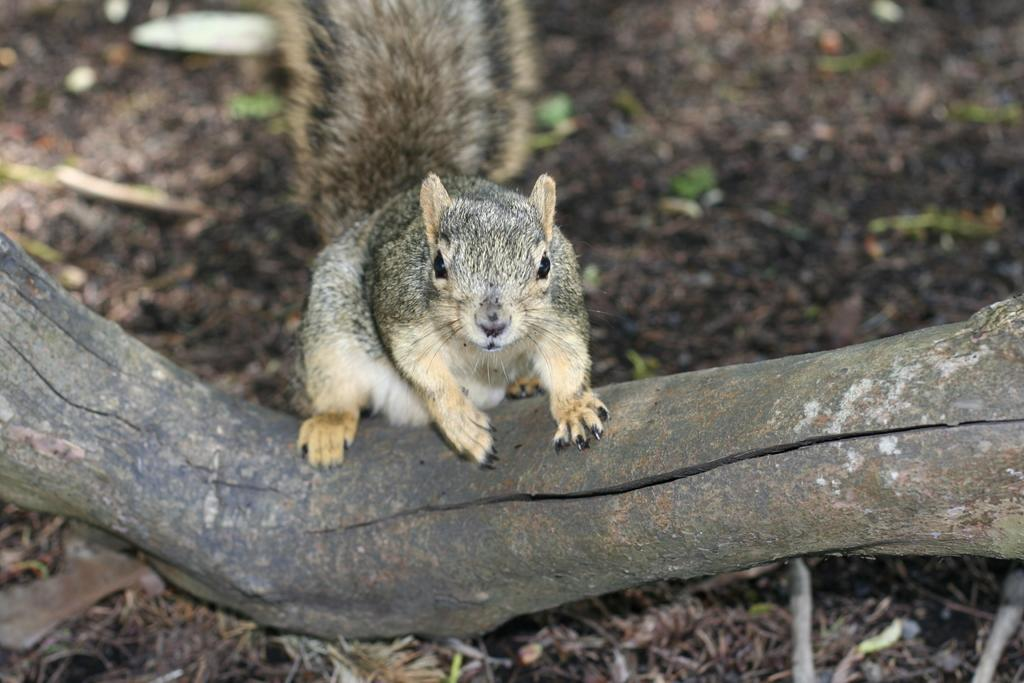What animal is the main subject of the image? There is a squirrel in the image. Where is the squirrel located in the image? The squirrel is in the center of the image. What is the squirrel standing on in the image? The squirrel is on a log. What type of camera is the squirrel using in the image? There is no camera present in the image. The squirrel is the main subject, and it is not using any camera in the image. 